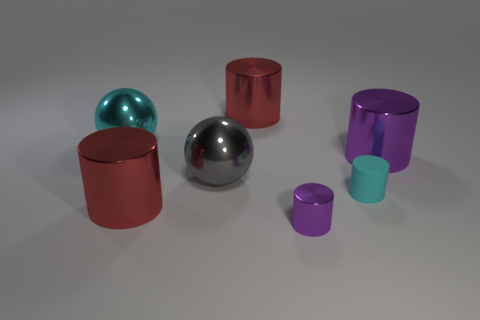Subtract all small matte cylinders. How many cylinders are left? 4 Add 1 large purple shiny objects. How many objects exist? 8 Subtract 1 spheres. How many spheres are left? 1 Subtract all purple balls. How many purple cylinders are left? 2 Subtract all purple cylinders. How many cylinders are left? 3 Subtract 0 purple blocks. How many objects are left? 7 Subtract all cylinders. How many objects are left? 2 Subtract all yellow spheres. Subtract all red cylinders. How many spheres are left? 2 Subtract all big balls. Subtract all purple things. How many objects are left? 3 Add 3 large cyan shiny objects. How many large cyan shiny objects are left? 4 